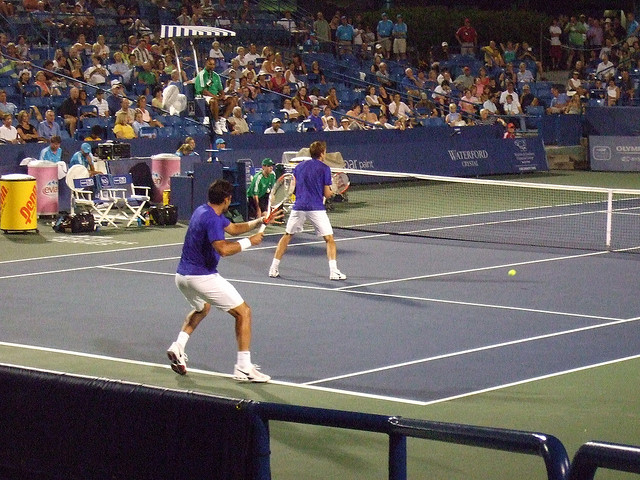Please transcribe the text in this image. WATERFORD 